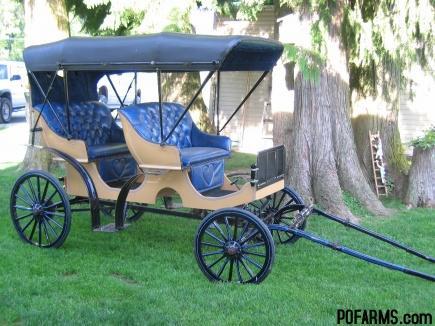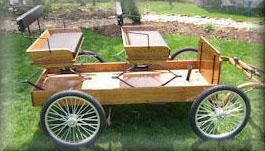The first image is the image on the left, the second image is the image on the right. For the images displayed, is the sentence "The wheels in one of the images have metal spokes." factually correct? Answer yes or no. Yes. 